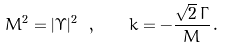Convert formula to latex. <formula><loc_0><loc_0><loc_500><loc_500>M ^ { 2 } = | \Upsilon | ^ { 2 } \ , \quad k = - \frac { \sqrt { 2 } \, \Gamma } { M } \, .</formula> 